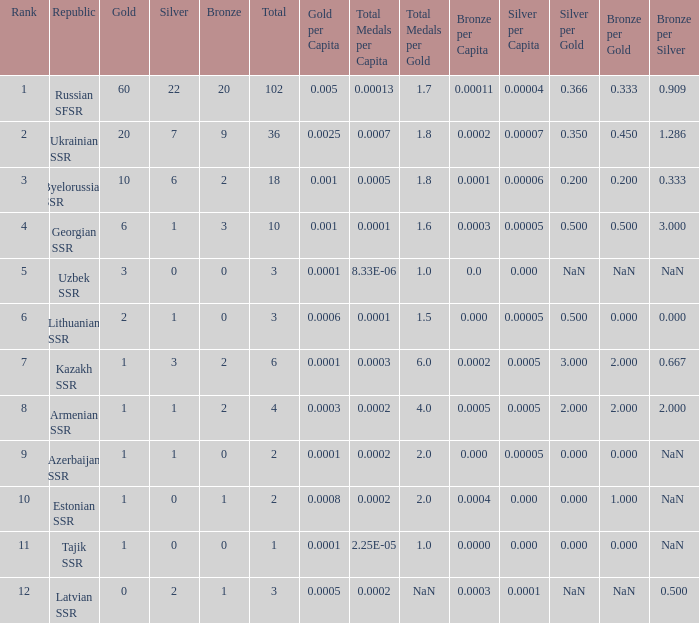What is the sum of bronzes for teams with more than 2 gold, ranked under 3, and less than 22 silver? 9.0. 